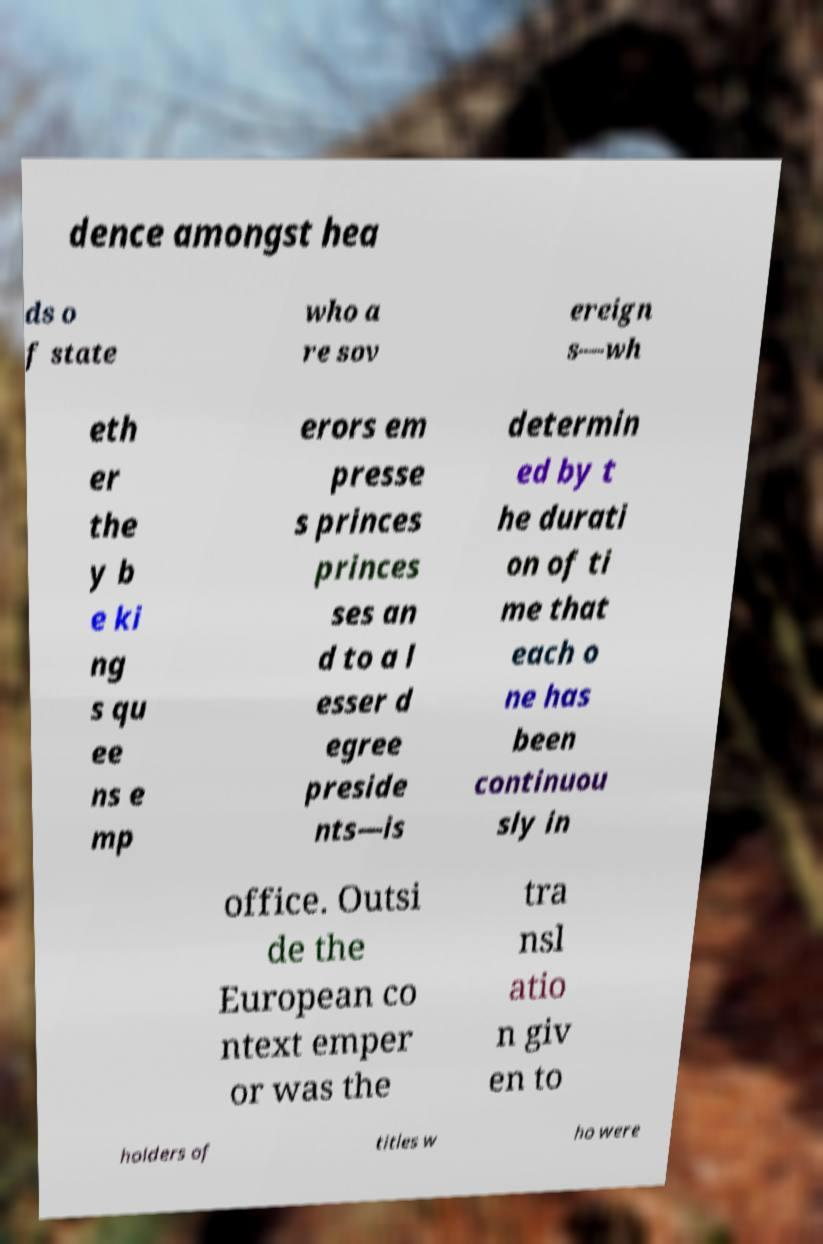For documentation purposes, I need the text within this image transcribed. Could you provide that? dence amongst hea ds o f state who a re sov ereign s—wh eth er the y b e ki ng s qu ee ns e mp erors em presse s princes princes ses an d to a l esser d egree preside nts—is determin ed by t he durati on of ti me that each o ne has been continuou sly in office. Outsi de the European co ntext emper or was the tra nsl atio n giv en to holders of titles w ho were 